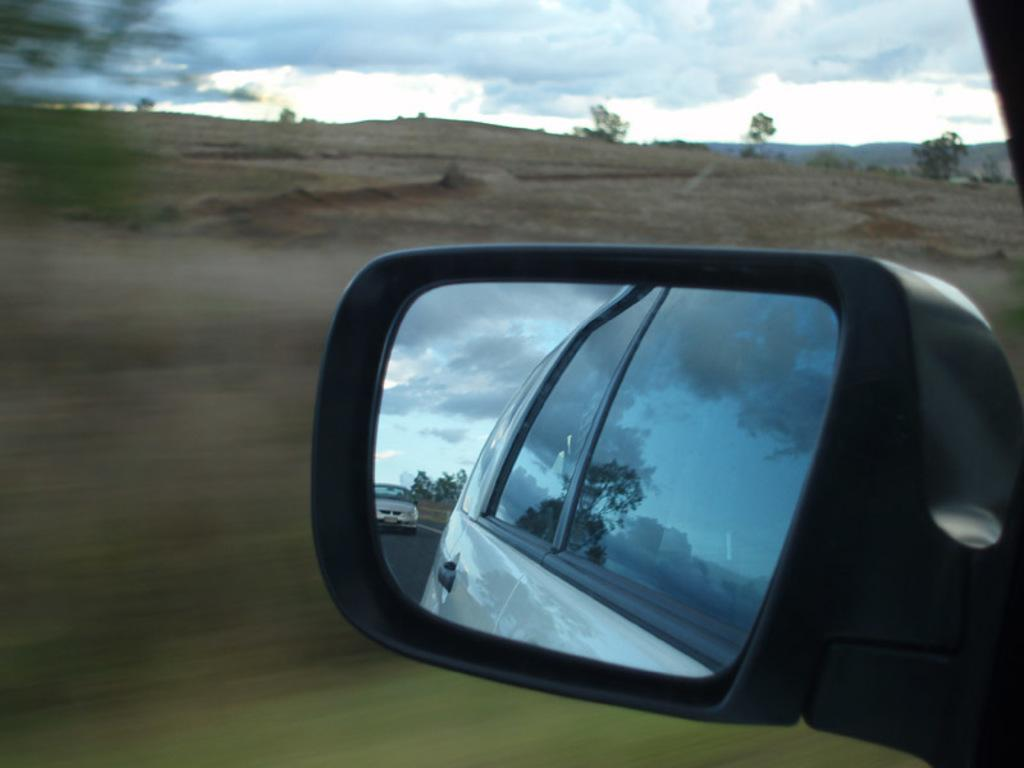What can be seen in the sky in the image? The sky is visible in the image, and there are clouds in the sky. What type of natural elements are present in the image? There are plants in the image. What object is reflecting the vehicles in the image? There is a mirror in the image that reflects the vehicles. What type of man-made structure is present in the image? There is a road in the image. What type of bread is being sold at the store in the image? There is no store or bread present in the image. What is the profit margin for the liquid products in the image? There are no liquid products or profit margins mentioned in the image. 